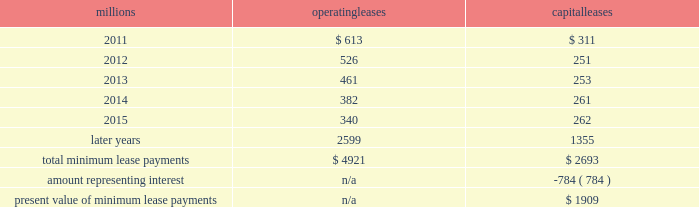2010 .
On november 1 , 2010 , we redeemed all $ 400 million of our outstanding 6.65% ( 6.65 % ) notes due january 15 , 2011 .
The redemption resulted in a $ 5 million early extinguishment charge .
Receivables securitization facility 2013 at december 31 , 2010 , we have recorded $ 100 million as secured debt under our receivables securitization facility .
( see further discussion of our receivables securitization facility in note 10. ) 15 .
Variable interest entities we have entered into various lease transactions in which the structure of the leases contain variable interest entities ( vies ) .
These vies were created solely for the purpose of doing lease transactions ( principally involving railroad equipment and facilities ) and have no other activities , assets or liabilities outside of the lease transactions .
Within these lease arrangements , we have the right to purchase some or all of the assets at fixed prices .
Depending on market conditions , fixed-price purchase options available in the leases could potentially provide benefits to us ; however , these benefits are not expected to be significant .
We maintain and operate the assets based on contractual obligations within the lease arrangements , which set specific guidelines consistent within the railroad industry .
As such , we have no control over activities that could materially impact the fair value of the leased assets .
We do not hold the power to direct the activities of the vies and , therefore , do not control the ongoing activities that have a significant impact on the economic performance of the vies .
Additionally , we do not have the obligation to absorb losses of the vies or the right to receive benefits of the vies that could potentially be significant to the we are not considered to be the primary beneficiary and do not consolidate these vies because our actions and decisions do not have the most significant effect on the vie 2019s performance and our fixed-price purchase price options are not considered to be potentially significant to the vie 2019s .
The future minimum lease payments associated with the vie leases totaled $ 4.2 billion as of december 31 , 2010 .
16 .
Leases we lease certain locomotives , freight cars , and other property .
The consolidated statement of financial position as of december 31 , 2010 and 2009 included $ 2520 million , net of $ 901 million of accumulated depreciation , and $ 2754 million , net of $ 927 million of accumulated depreciation , respectively , for properties held under capital leases .
A charge to income resulting from the depreciation for assets held under capital leases is included within depreciation expense in our consolidated statements of income .
Future minimum lease payments for operating and capital leases with initial or remaining non-cancelable lease terms in excess of one year as of december 31 , 2010 , were as follows : millions operating leases capital leases .
The majority of capital lease payments relate to locomotives .
Rent expense for operating leases with terms exceeding one month was $ 624 million in 2010 , $ 686 million in 2009 , and $ 747 million in 2008 .
When cash rental payments are not made on a straight-line basis , we recognize variable rental expense on a straight-line basis over the lease term .
Contingent rentals and sub-rentals are not significant. .
In 2010 what was the percent of the early extinguishment charge to the amount of the outstanding 6.65% ( 6.65 % ) notes due january 15 , 2011? 
Computations: (5 / 400)
Answer: 0.0125. 